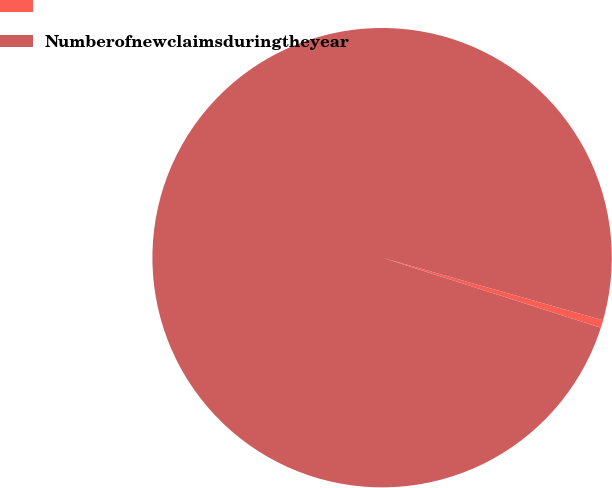Convert chart. <chart><loc_0><loc_0><loc_500><loc_500><pie_chart><ecel><fcel>Numberofnewclaimsduringtheyear<nl><fcel>0.54%<fcel>99.46%<nl></chart> 